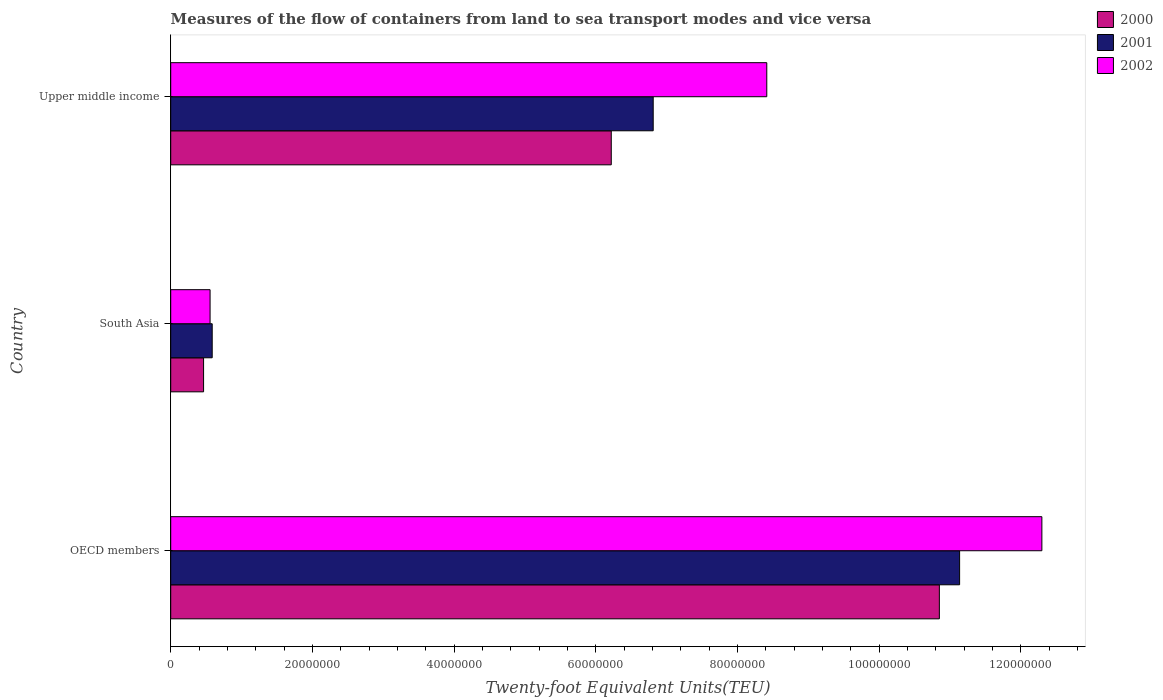Are the number of bars per tick equal to the number of legend labels?
Your answer should be compact. Yes. Are the number of bars on each tick of the Y-axis equal?
Your answer should be very brief. Yes. How many bars are there on the 1st tick from the top?
Ensure brevity in your answer.  3. How many bars are there on the 3rd tick from the bottom?
Your answer should be compact. 3. What is the container port traffic in 2002 in OECD members?
Ensure brevity in your answer.  1.23e+08. Across all countries, what is the maximum container port traffic in 2000?
Your response must be concise. 1.09e+08. Across all countries, what is the minimum container port traffic in 2000?
Your answer should be very brief. 4.64e+06. In which country was the container port traffic in 2002 minimum?
Your response must be concise. South Asia. What is the total container port traffic in 2000 in the graph?
Offer a terse response. 1.75e+08. What is the difference between the container port traffic in 2001 in OECD members and that in Upper middle income?
Provide a short and direct response. 4.33e+07. What is the difference between the container port traffic in 2001 in Upper middle income and the container port traffic in 2000 in South Asia?
Keep it short and to the point. 6.35e+07. What is the average container port traffic in 2000 per country?
Your answer should be very brief. 5.85e+07. What is the difference between the container port traffic in 2000 and container port traffic in 2001 in OECD members?
Ensure brevity in your answer.  -2.86e+06. What is the ratio of the container port traffic in 2002 in OECD members to that in South Asia?
Make the answer very short. 22.13. What is the difference between the highest and the second highest container port traffic in 2001?
Your answer should be very brief. 4.33e+07. What is the difference between the highest and the lowest container port traffic in 2000?
Give a very brief answer. 1.04e+08. In how many countries, is the container port traffic in 2001 greater than the average container port traffic in 2001 taken over all countries?
Offer a very short reply. 2. Is the sum of the container port traffic in 2002 in OECD members and Upper middle income greater than the maximum container port traffic in 2001 across all countries?
Offer a very short reply. Yes. What does the 2nd bar from the bottom in Upper middle income represents?
Keep it short and to the point. 2001. Is it the case that in every country, the sum of the container port traffic in 2002 and container port traffic in 2001 is greater than the container port traffic in 2000?
Your answer should be very brief. Yes. How many bars are there?
Keep it short and to the point. 9. Are all the bars in the graph horizontal?
Provide a succinct answer. Yes. How many countries are there in the graph?
Offer a terse response. 3. What is the difference between two consecutive major ticks on the X-axis?
Keep it short and to the point. 2.00e+07. Are the values on the major ticks of X-axis written in scientific E-notation?
Your answer should be compact. No. Does the graph contain any zero values?
Ensure brevity in your answer.  No. How are the legend labels stacked?
Ensure brevity in your answer.  Vertical. What is the title of the graph?
Provide a short and direct response. Measures of the flow of containers from land to sea transport modes and vice versa. Does "2012" appear as one of the legend labels in the graph?
Give a very brief answer. No. What is the label or title of the X-axis?
Make the answer very short. Twenty-foot Equivalent Units(TEU). What is the Twenty-foot Equivalent Units(TEU) of 2000 in OECD members?
Make the answer very short. 1.09e+08. What is the Twenty-foot Equivalent Units(TEU) of 2001 in OECD members?
Your response must be concise. 1.11e+08. What is the Twenty-foot Equivalent Units(TEU) in 2002 in OECD members?
Offer a very short reply. 1.23e+08. What is the Twenty-foot Equivalent Units(TEU) of 2000 in South Asia?
Keep it short and to the point. 4.64e+06. What is the Twenty-foot Equivalent Units(TEU) of 2001 in South Asia?
Offer a terse response. 5.86e+06. What is the Twenty-foot Equivalent Units(TEU) in 2002 in South Asia?
Offer a very short reply. 5.56e+06. What is the Twenty-foot Equivalent Units(TEU) in 2000 in Upper middle income?
Your response must be concise. 6.22e+07. What is the Twenty-foot Equivalent Units(TEU) in 2001 in Upper middle income?
Offer a very short reply. 6.81e+07. What is the Twenty-foot Equivalent Units(TEU) in 2002 in Upper middle income?
Make the answer very short. 8.42e+07. Across all countries, what is the maximum Twenty-foot Equivalent Units(TEU) in 2000?
Your response must be concise. 1.09e+08. Across all countries, what is the maximum Twenty-foot Equivalent Units(TEU) of 2001?
Provide a short and direct response. 1.11e+08. Across all countries, what is the maximum Twenty-foot Equivalent Units(TEU) in 2002?
Ensure brevity in your answer.  1.23e+08. Across all countries, what is the minimum Twenty-foot Equivalent Units(TEU) of 2000?
Provide a succinct answer. 4.64e+06. Across all countries, what is the minimum Twenty-foot Equivalent Units(TEU) in 2001?
Keep it short and to the point. 5.86e+06. Across all countries, what is the minimum Twenty-foot Equivalent Units(TEU) of 2002?
Keep it short and to the point. 5.56e+06. What is the total Twenty-foot Equivalent Units(TEU) of 2000 in the graph?
Your response must be concise. 1.75e+08. What is the total Twenty-foot Equivalent Units(TEU) in 2001 in the graph?
Your response must be concise. 1.85e+08. What is the total Twenty-foot Equivalent Units(TEU) in 2002 in the graph?
Ensure brevity in your answer.  2.13e+08. What is the difference between the Twenty-foot Equivalent Units(TEU) in 2000 in OECD members and that in South Asia?
Your answer should be compact. 1.04e+08. What is the difference between the Twenty-foot Equivalent Units(TEU) of 2001 in OECD members and that in South Asia?
Your answer should be compact. 1.06e+08. What is the difference between the Twenty-foot Equivalent Units(TEU) of 2002 in OECD members and that in South Asia?
Your response must be concise. 1.17e+08. What is the difference between the Twenty-foot Equivalent Units(TEU) in 2000 in OECD members and that in Upper middle income?
Your answer should be compact. 4.63e+07. What is the difference between the Twenty-foot Equivalent Units(TEU) in 2001 in OECD members and that in Upper middle income?
Offer a terse response. 4.33e+07. What is the difference between the Twenty-foot Equivalent Units(TEU) of 2002 in OECD members and that in Upper middle income?
Ensure brevity in your answer.  3.88e+07. What is the difference between the Twenty-foot Equivalent Units(TEU) in 2000 in South Asia and that in Upper middle income?
Provide a succinct answer. -5.76e+07. What is the difference between the Twenty-foot Equivalent Units(TEU) in 2001 in South Asia and that in Upper middle income?
Give a very brief answer. -6.23e+07. What is the difference between the Twenty-foot Equivalent Units(TEU) in 2002 in South Asia and that in Upper middle income?
Provide a succinct answer. -7.86e+07. What is the difference between the Twenty-foot Equivalent Units(TEU) of 2000 in OECD members and the Twenty-foot Equivalent Units(TEU) of 2001 in South Asia?
Offer a terse response. 1.03e+08. What is the difference between the Twenty-foot Equivalent Units(TEU) in 2000 in OECD members and the Twenty-foot Equivalent Units(TEU) in 2002 in South Asia?
Your answer should be very brief. 1.03e+08. What is the difference between the Twenty-foot Equivalent Units(TEU) in 2001 in OECD members and the Twenty-foot Equivalent Units(TEU) in 2002 in South Asia?
Your answer should be very brief. 1.06e+08. What is the difference between the Twenty-foot Equivalent Units(TEU) in 2000 in OECD members and the Twenty-foot Equivalent Units(TEU) in 2001 in Upper middle income?
Give a very brief answer. 4.04e+07. What is the difference between the Twenty-foot Equivalent Units(TEU) in 2000 in OECD members and the Twenty-foot Equivalent Units(TEU) in 2002 in Upper middle income?
Offer a terse response. 2.44e+07. What is the difference between the Twenty-foot Equivalent Units(TEU) of 2001 in OECD members and the Twenty-foot Equivalent Units(TEU) of 2002 in Upper middle income?
Your response must be concise. 2.72e+07. What is the difference between the Twenty-foot Equivalent Units(TEU) in 2000 in South Asia and the Twenty-foot Equivalent Units(TEU) in 2001 in Upper middle income?
Your answer should be compact. -6.35e+07. What is the difference between the Twenty-foot Equivalent Units(TEU) in 2000 in South Asia and the Twenty-foot Equivalent Units(TEU) in 2002 in Upper middle income?
Offer a terse response. -7.95e+07. What is the difference between the Twenty-foot Equivalent Units(TEU) in 2001 in South Asia and the Twenty-foot Equivalent Units(TEU) in 2002 in Upper middle income?
Offer a very short reply. -7.83e+07. What is the average Twenty-foot Equivalent Units(TEU) of 2000 per country?
Your response must be concise. 5.85e+07. What is the average Twenty-foot Equivalent Units(TEU) of 2001 per country?
Ensure brevity in your answer.  6.18e+07. What is the average Twenty-foot Equivalent Units(TEU) of 2002 per country?
Your answer should be compact. 7.09e+07. What is the difference between the Twenty-foot Equivalent Units(TEU) in 2000 and Twenty-foot Equivalent Units(TEU) in 2001 in OECD members?
Your response must be concise. -2.86e+06. What is the difference between the Twenty-foot Equivalent Units(TEU) in 2000 and Twenty-foot Equivalent Units(TEU) in 2002 in OECD members?
Offer a very short reply. -1.45e+07. What is the difference between the Twenty-foot Equivalent Units(TEU) in 2001 and Twenty-foot Equivalent Units(TEU) in 2002 in OECD members?
Provide a succinct answer. -1.16e+07. What is the difference between the Twenty-foot Equivalent Units(TEU) of 2000 and Twenty-foot Equivalent Units(TEU) of 2001 in South Asia?
Keep it short and to the point. -1.22e+06. What is the difference between the Twenty-foot Equivalent Units(TEU) of 2000 and Twenty-foot Equivalent Units(TEU) of 2002 in South Asia?
Provide a succinct answer. -9.18e+05. What is the difference between the Twenty-foot Equivalent Units(TEU) of 2001 and Twenty-foot Equivalent Units(TEU) of 2002 in South Asia?
Give a very brief answer. 2.99e+05. What is the difference between the Twenty-foot Equivalent Units(TEU) in 2000 and Twenty-foot Equivalent Units(TEU) in 2001 in Upper middle income?
Ensure brevity in your answer.  -5.92e+06. What is the difference between the Twenty-foot Equivalent Units(TEU) of 2000 and Twenty-foot Equivalent Units(TEU) of 2002 in Upper middle income?
Your response must be concise. -2.20e+07. What is the difference between the Twenty-foot Equivalent Units(TEU) in 2001 and Twenty-foot Equivalent Units(TEU) in 2002 in Upper middle income?
Make the answer very short. -1.60e+07. What is the ratio of the Twenty-foot Equivalent Units(TEU) of 2000 in OECD members to that in South Asia?
Your answer should be compact. 23.39. What is the ratio of the Twenty-foot Equivalent Units(TEU) of 2001 in OECD members to that in South Asia?
Ensure brevity in your answer.  19.02. What is the ratio of the Twenty-foot Equivalent Units(TEU) in 2002 in OECD members to that in South Asia?
Ensure brevity in your answer.  22.13. What is the ratio of the Twenty-foot Equivalent Units(TEU) in 2000 in OECD members to that in Upper middle income?
Offer a terse response. 1.74. What is the ratio of the Twenty-foot Equivalent Units(TEU) of 2001 in OECD members to that in Upper middle income?
Offer a very short reply. 1.64. What is the ratio of the Twenty-foot Equivalent Units(TEU) in 2002 in OECD members to that in Upper middle income?
Offer a very short reply. 1.46. What is the ratio of the Twenty-foot Equivalent Units(TEU) in 2000 in South Asia to that in Upper middle income?
Provide a succinct answer. 0.07. What is the ratio of the Twenty-foot Equivalent Units(TEU) in 2001 in South Asia to that in Upper middle income?
Provide a short and direct response. 0.09. What is the ratio of the Twenty-foot Equivalent Units(TEU) in 2002 in South Asia to that in Upper middle income?
Offer a very short reply. 0.07. What is the difference between the highest and the second highest Twenty-foot Equivalent Units(TEU) in 2000?
Your response must be concise. 4.63e+07. What is the difference between the highest and the second highest Twenty-foot Equivalent Units(TEU) in 2001?
Provide a succinct answer. 4.33e+07. What is the difference between the highest and the second highest Twenty-foot Equivalent Units(TEU) in 2002?
Give a very brief answer. 3.88e+07. What is the difference between the highest and the lowest Twenty-foot Equivalent Units(TEU) in 2000?
Make the answer very short. 1.04e+08. What is the difference between the highest and the lowest Twenty-foot Equivalent Units(TEU) of 2001?
Your answer should be compact. 1.06e+08. What is the difference between the highest and the lowest Twenty-foot Equivalent Units(TEU) in 2002?
Provide a succinct answer. 1.17e+08. 